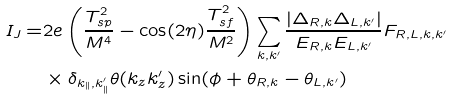<formula> <loc_0><loc_0><loc_500><loc_500>I _ { J } = & 2 e \left ( \frac { T _ { s p } ^ { 2 } } { M ^ { 4 } } - \cos ( 2 \eta ) \frac { T _ { s f } ^ { 2 } } { M ^ { 2 } } \right ) \sum _ { { k } , { k } ^ { \prime } } \frac { | \Delta _ { R , { k } } \Delta _ { L , { k } ^ { \prime } } | } { E _ { R , { k } } E _ { L , { k } ^ { \prime } } } F _ { R , L , { k } , { k } ^ { \prime } } \\ & \times \delta _ { { k } _ { \| } , { k } ^ { \prime } _ { \| } } \theta ( k _ { z } k ^ { \prime } _ { z } ) \sin ( \phi + \theta _ { R , { k } } - \theta _ { L , { k } ^ { \prime } } )</formula> 